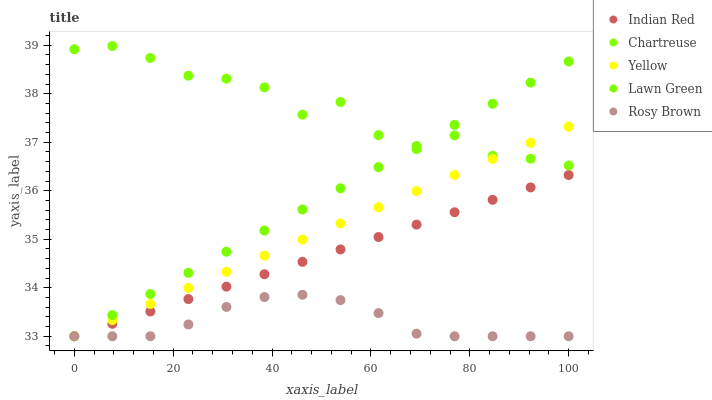Does Rosy Brown have the minimum area under the curve?
Answer yes or no. Yes. Does Chartreuse have the maximum area under the curve?
Answer yes or no. Yes. Does Chartreuse have the minimum area under the curve?
Answer yes or no. No. Does Rosy Brown have the maximum area under the curve?
Answer yes or no. No. Is Lawn Green the smoothest?
Answer yes or no. Yes. Is Chartreuse the roughest?
Answer yes or no. Yes. Is Rosy Brown the smoothest?
Answer yes or no. No. Is Rosy Brown the roughest?
Answer yes or no. No. Does Lawn Green have the lowest value?
Answer yes or no. Yes. Does Chartreuse have the lowest value?
Answer yes or no. No. Does Chartreuse have the highest value?
Answer yes or no. Yes. Does Rosy Brown have the highest value?
Answer yes or no. No. Is Rosy Brown less than Chartreuse?
Answer yes or no. Yes. Is Chartreuse greater than Rosy Brown?
Answer yes or no. Yes. Does Yellow intersect Lawn Green?
Answer yes or no. Yes. Is Yellow less than Lawn Green?
Answer yes or no. No. Is Yellow greater than Lawn Green?
Answer yes or no. No. Does Rosy Brown intersect Chartreuse?
Answer yes or no. No. 